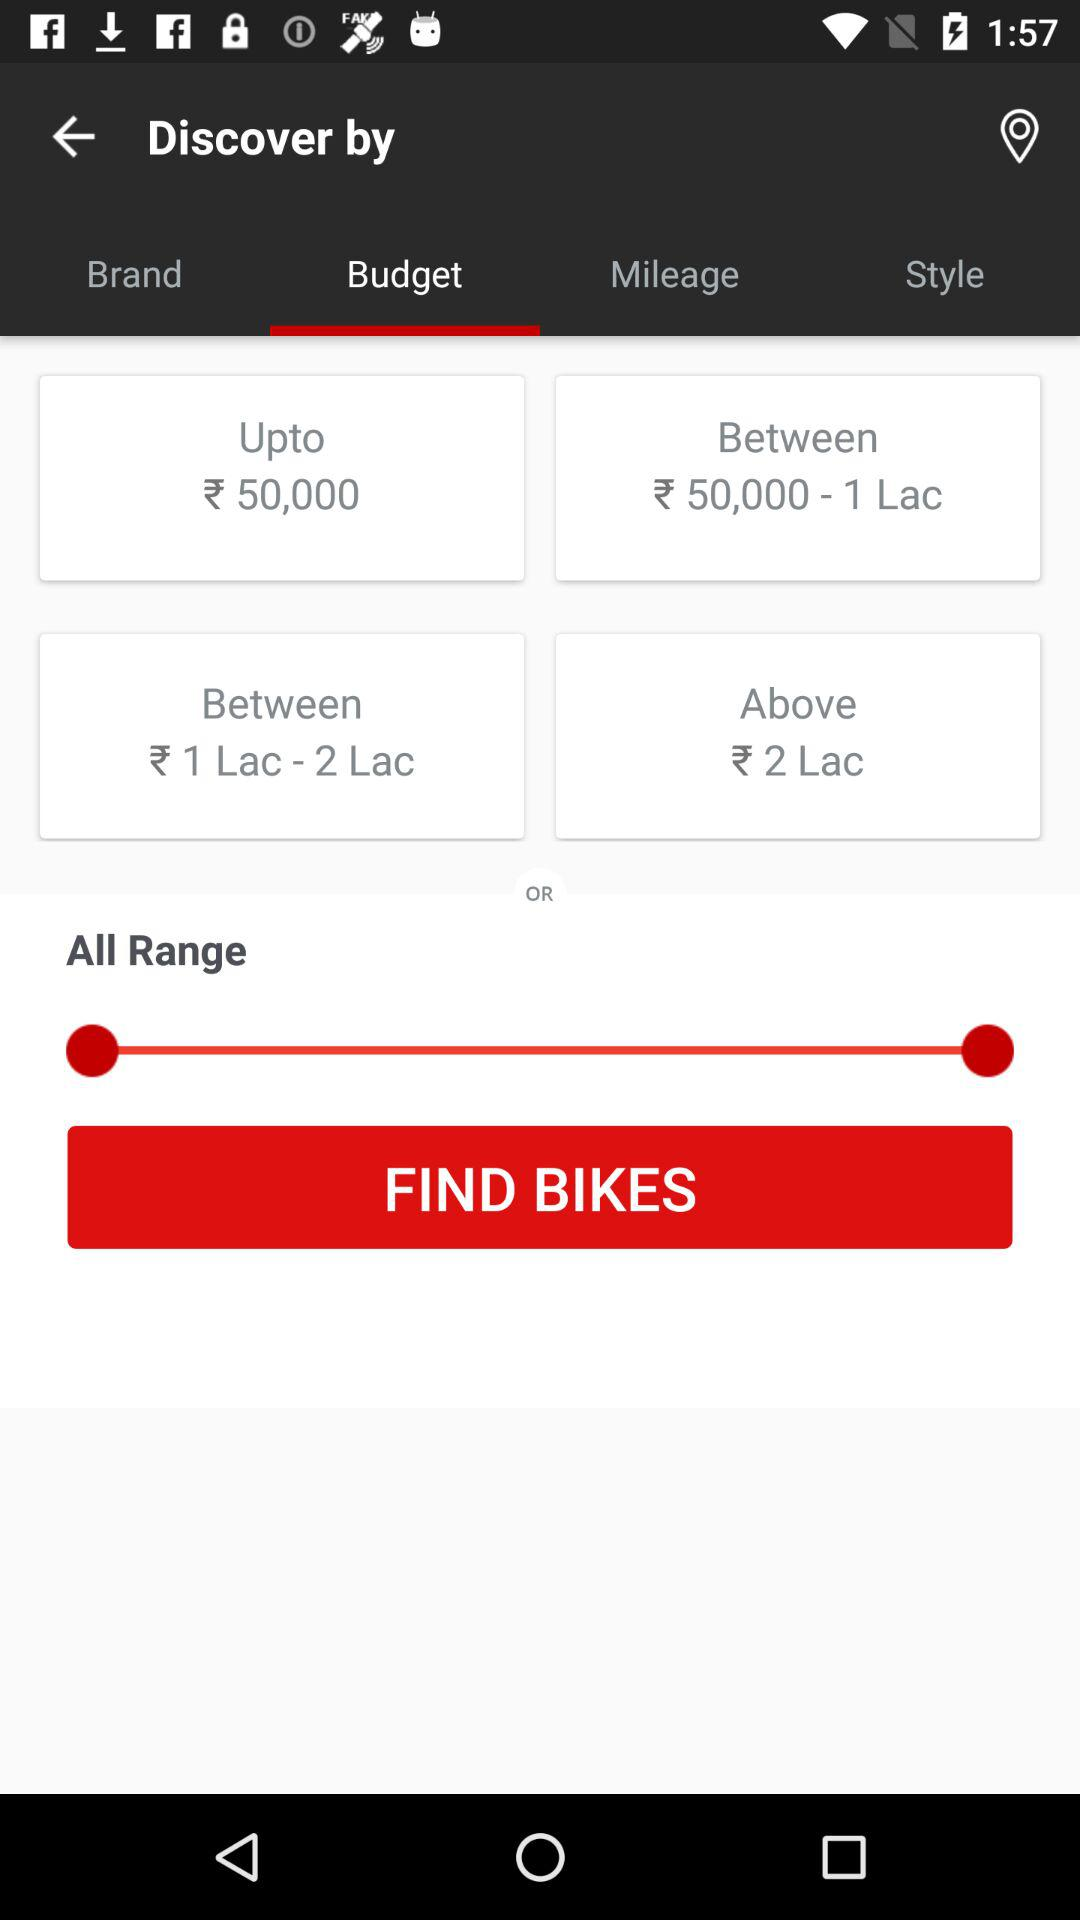What are the budget ranges? The budget ranges are "Upto ₹ 50,000", "Between ₹ 50,000 - 1 Lac", "Between 1 Lac - 2 Lac" and "Above ₹ 2 Lac". 